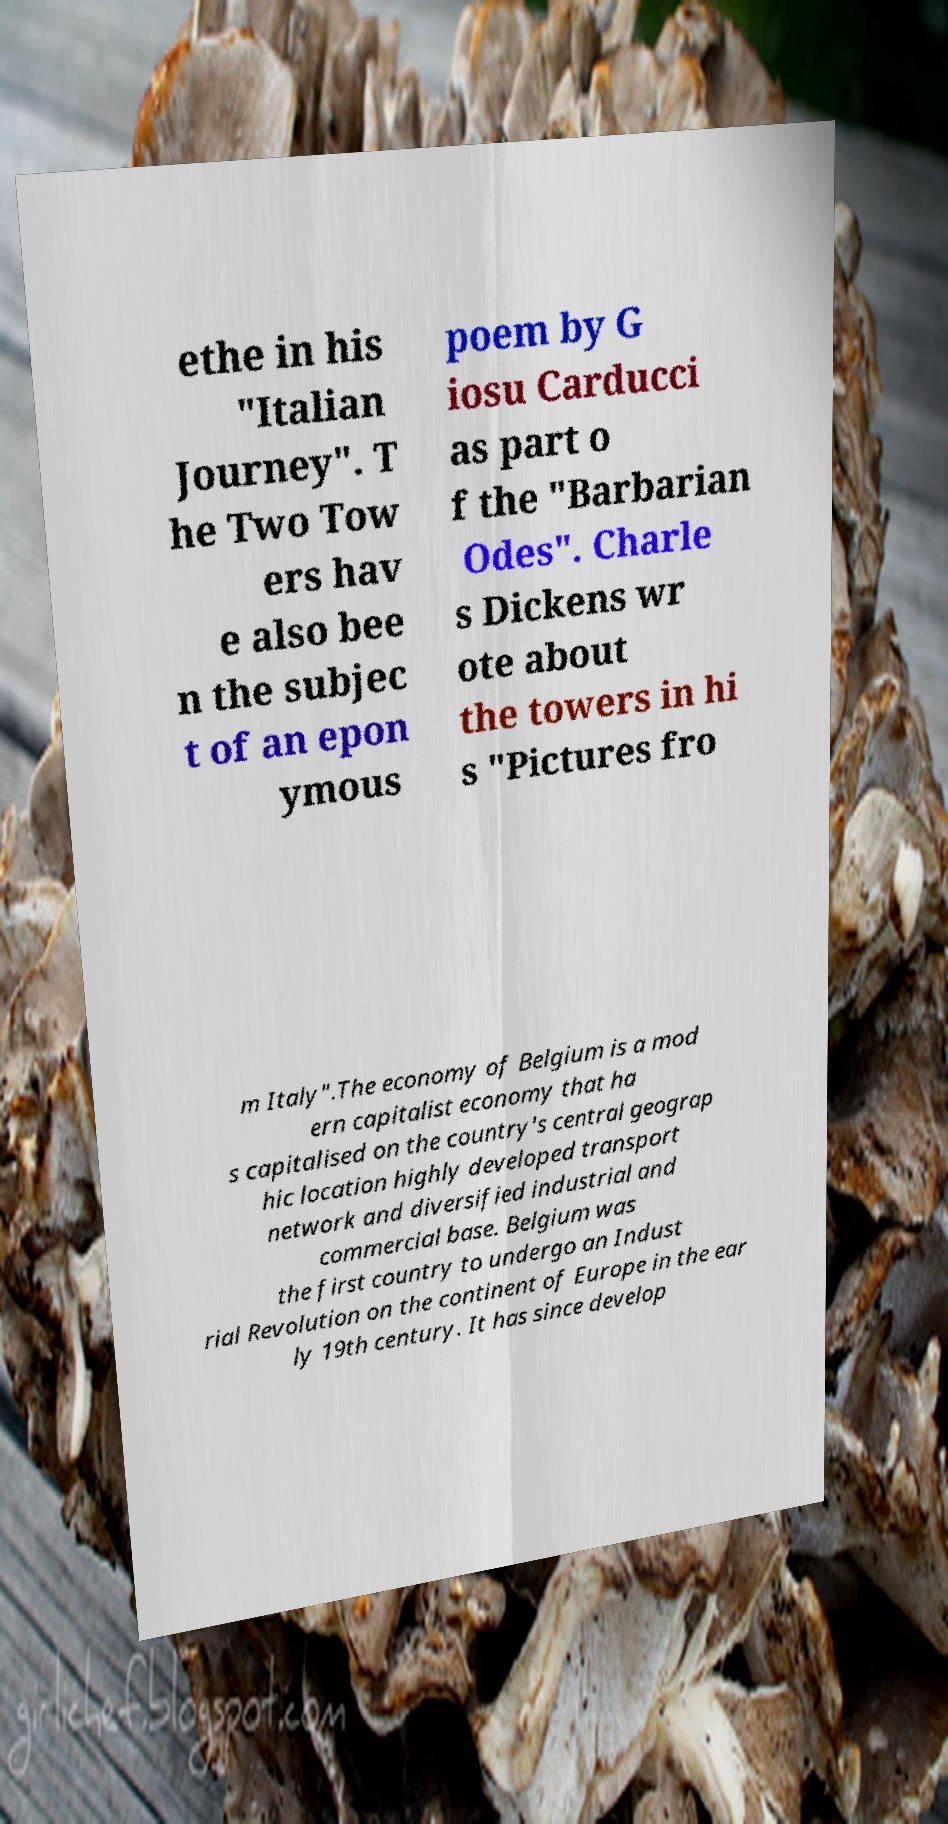Please identify and transcribe the text found in this image. ethe in his "Italian Journey". T he Two Tow ers hav e also bee n the subjec t of an epon ymous poem by G iosu Carducci as part o f the "Barbarian Odes". Charle s Dickens wr ote about the towers in hi s "Pictures fro m Italy".The economy of Belgium is a mod ern capitalist economy that ha s capitalised on the country's central geograp hic location highly developed transport network and diversified industrial and commercial base. Belgium was the first country to undergo an Indust rial Revolution on the continent of Europe in the ear ly 19th century. It has since develop 